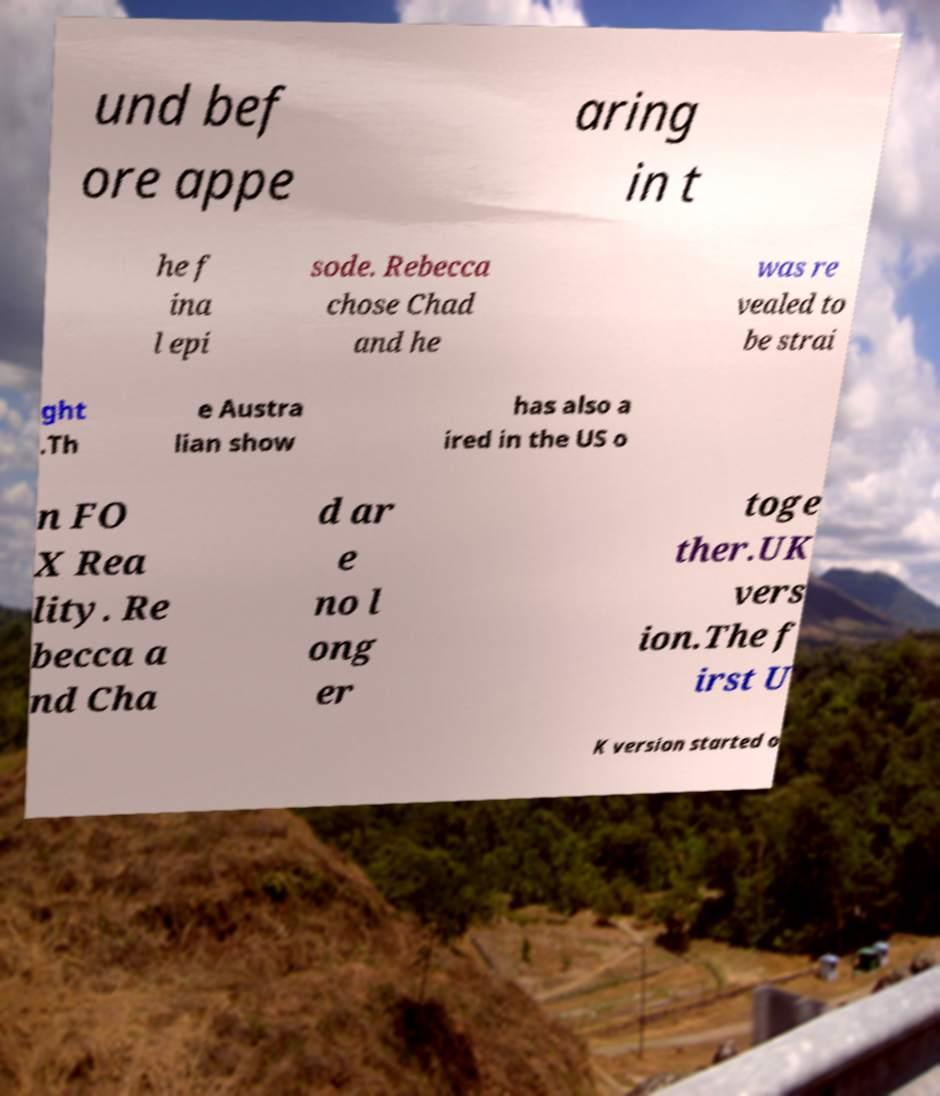Please identify and transcribe the text found in this image. und bef ore appe aring in t he f ina l epi sode. Rebecca chose Chad and he was re vealed to be strai ght .Th e Austra lian show has also a ired in the US o n FO X Rea lity. Re becca a nd Cha d ar e no l ong er toge ther.UK vers ion.The f irst U K version started o 